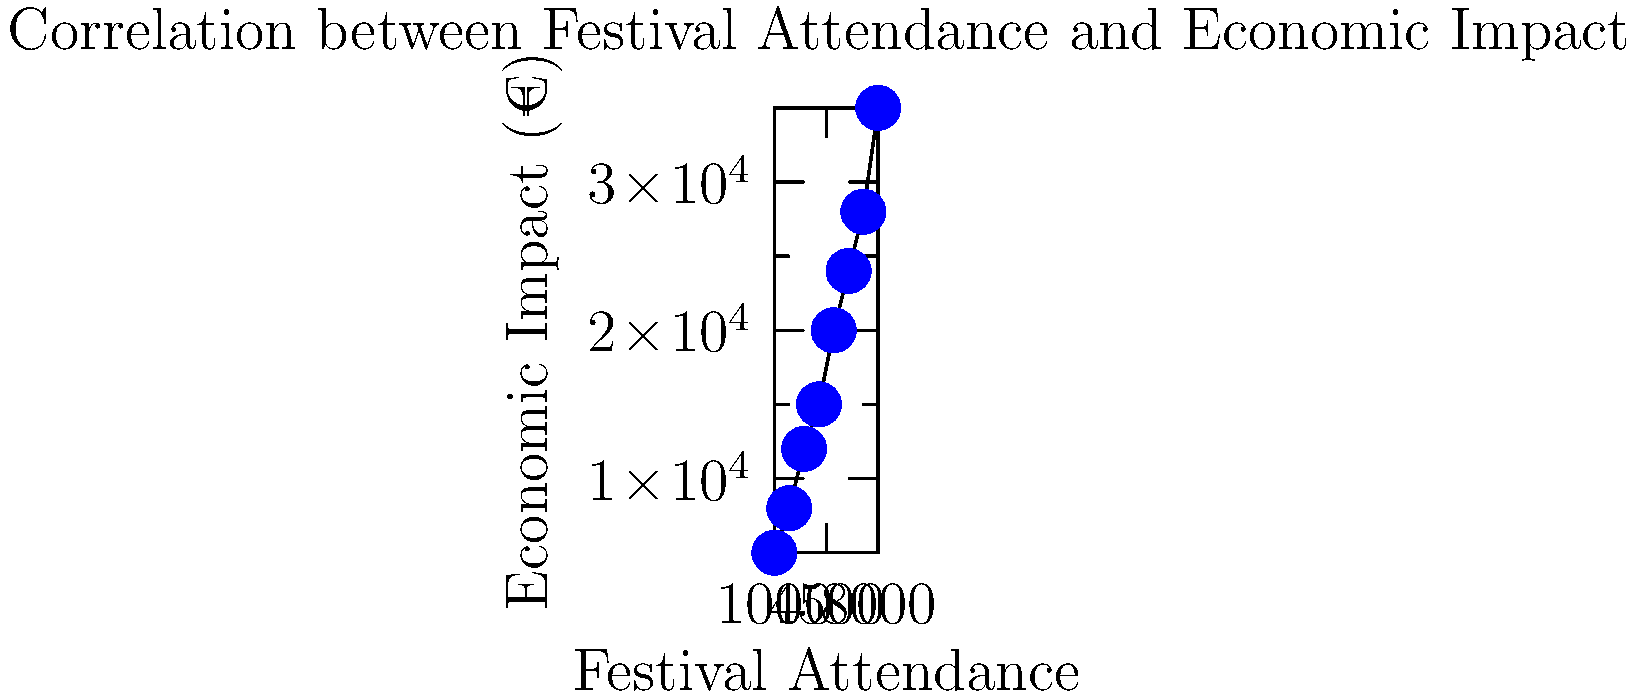Based on the scatter plot showing the relationship between local festival attendance and economic impact in your rural Irish town, what can be inferred about the economic benefit of increasing festival attendance from 3000 to 7000 people? Express your answer as a percentage increase in economic impact. To answer this question, we need to follow these steps:

1. Identify the economic impact for 3000 and 7000 attendees:
   - At 3000 attendees, the economic impact is approximately €12,000
   - At 7000 attendees, the economic impact is approximately €28,000

2. Calculate the difference in economic impact:
   €28,000 - €12,000 = €16,000

3. Calculate the percentage increase:
   Percentage increase = (Increase / Original Value) * 100
   = (16,000 / 12,000) * 100
   = 1.3333 * 100
   = 133.33%

4. Round to the nearest whole percentage:
   133% increase

This calculation shows that increasing festival attendance from 3000 to 7000 people results in a significant economic boost for the rural Irish town, with the economic impact more than doubling.
Answer: 133% 